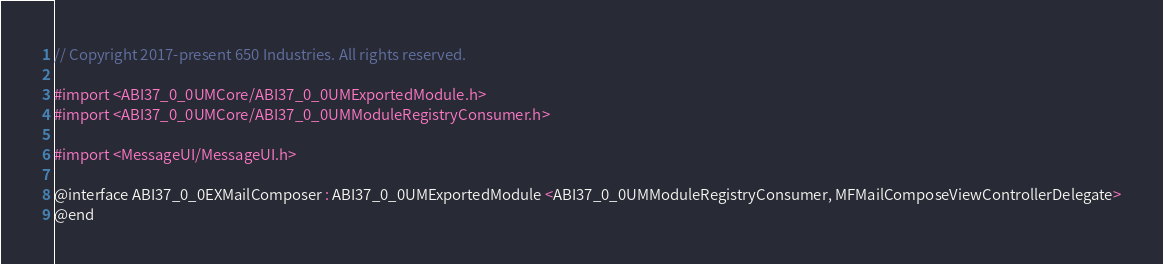Convert code to text. <code><loc_0><loc_0><loc_500><loc_500><_C_>// Copyright 2017-present 650 Industries. All rights reserved.

#import <ABI37_0_0UMCore/ABI37_0_0UMExportedModule.h>
#import <ABI37_0_0UMCore/ABI37_0_0UMModuleRegistryConsumer.h>

#import <MessageUI/MessageUI.h>

@interface ABI37_0_0EXMailComposer : ABI37_0_0UMExportedModule <ABI37_0_0UMModuleRegistryConsumer, MFMailComposeViewControllerDelegate>
@end
</code> 